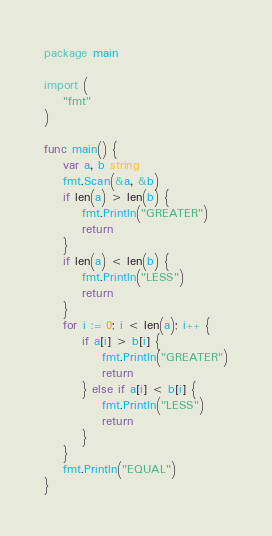<code> <loc_0><loc_0><loc_500><loc_500><_Go_>package main

import (
	"fmt"
)

func main() {
	var a, b string
	fmt.Scan(&a, &b)
	if len(a) > len(b) {
		fmt.Println("GREATER")
		return
	}
	if len(a) < len(b) {
		fmt.Println("LESS")
		return
	}
	for i := 0; i < len(a); i++ {
		if a[i] > b[i] {
			fmt.Println("GREATER")
			return
		} else if a[i] < b[i] {
			fmt.Println("LESS")
			return
		}
	}
	fmt.Println("EQUAL")
}</code> 